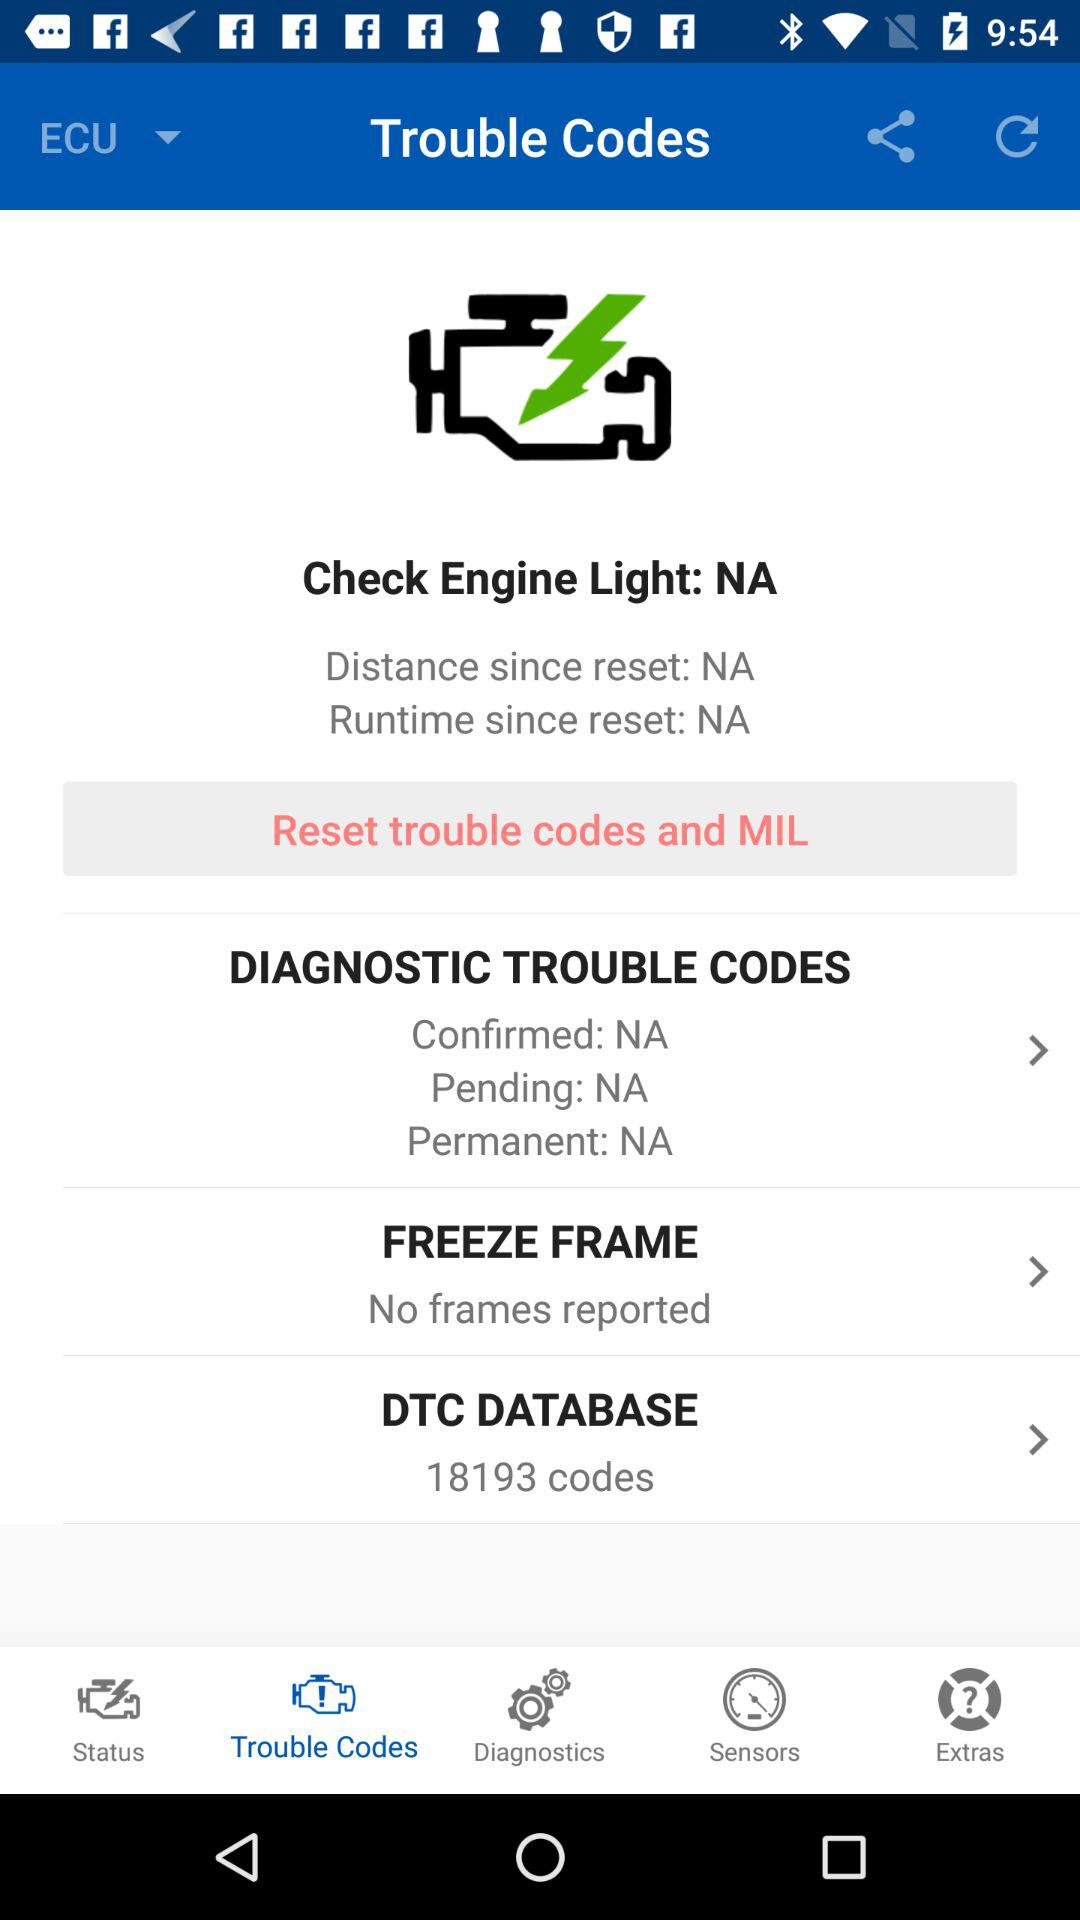Is there any freeze frame reported? There are no reported freeze frames. 